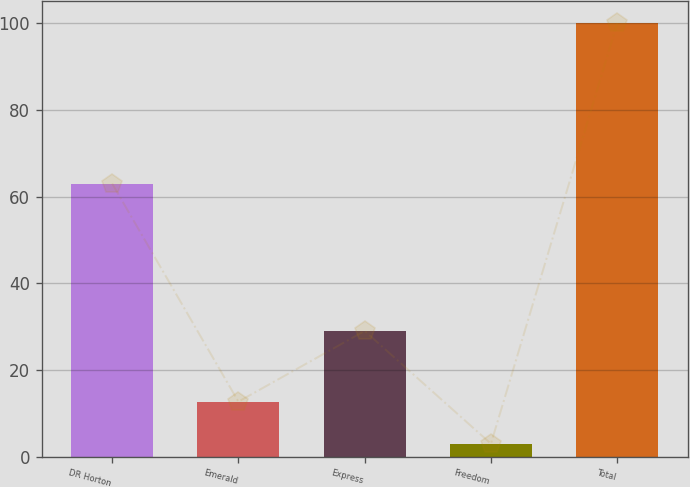<chart> <loc_0><loc_0><loc_500><loc_500><bar_chart><fcel>DR Horton<fcel>Emerald<fcel>Express<fcel>Freedom<fcel>Total<nl><fcel>63<fcel>12.7<fcel>29<fcel>3<fcel>100<nl></chart> 